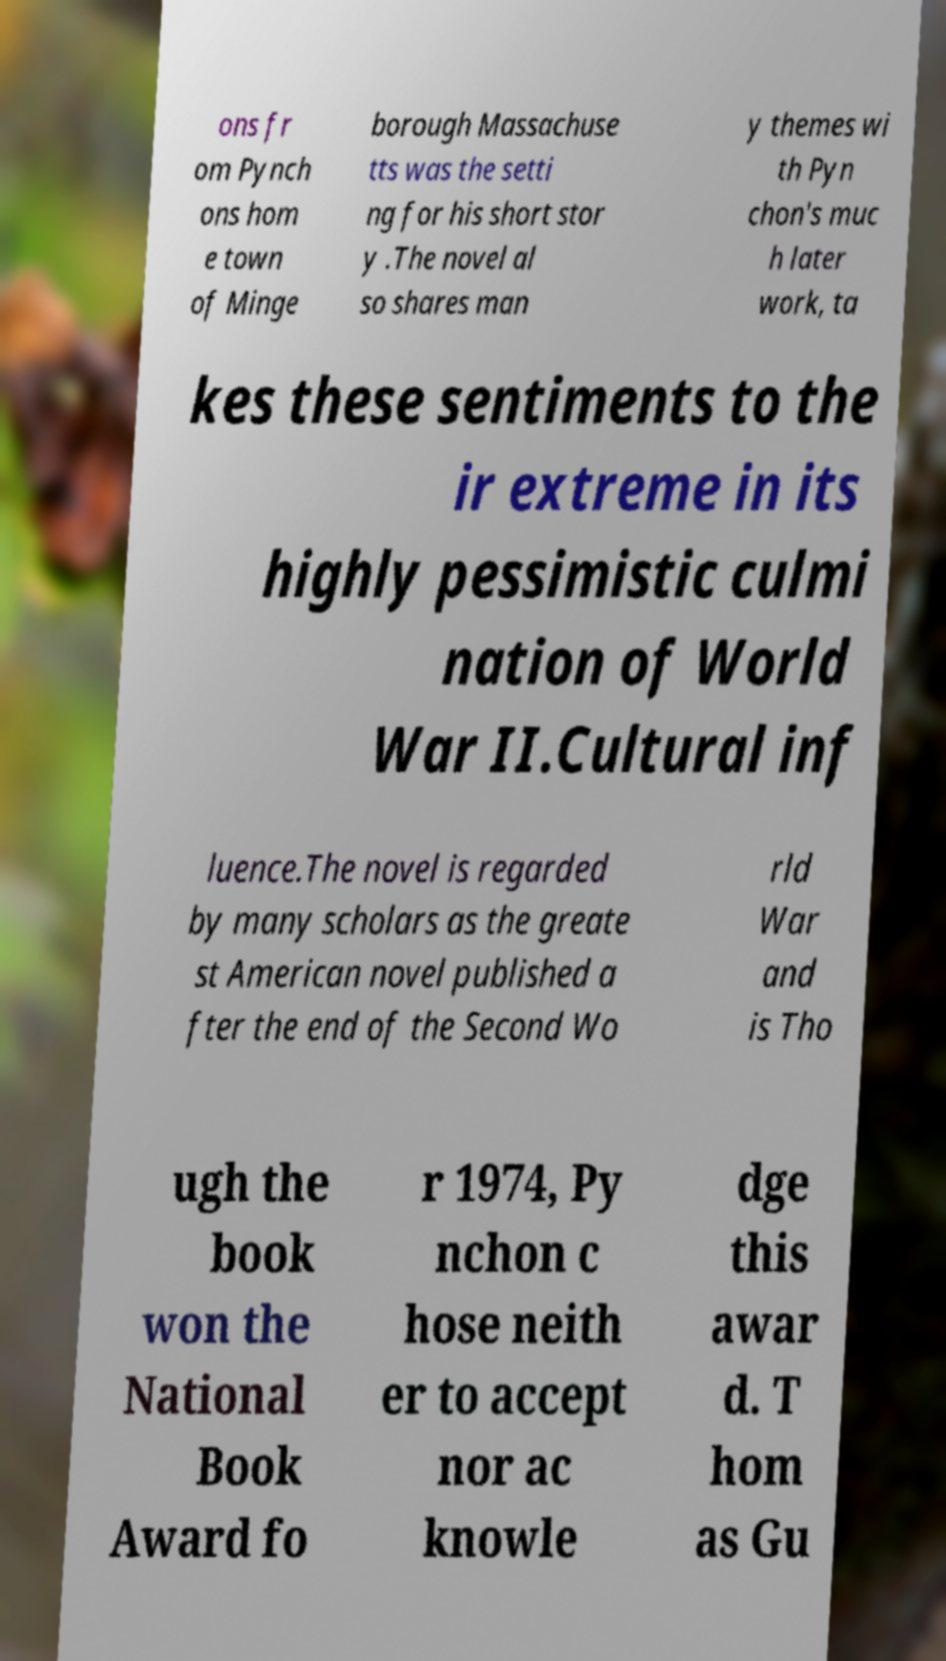Can you read and provide the text displayed in the image?This photo seems to have some interesting text. Can you extract and type it out for me? ons fr om Pynch ons hom e town of Minge borough Massachuse tts was the setti ng for his short stor y .The novel al so shares man y themes wi th Pyn chon's muc h later work, ta kes these sentiments to the ir extreme in its highly pessimistic culmi nation of World War II.Cultural inf luence.The novel is regarded by many scholars as the greate st American novel published a fter the end of the Second Wo rld War and is Tho ugh the book won the National Book Award fo r 1974, Py nchon c hose neith er to accept nor ac knowle dge this awar d. T hom as Gu 